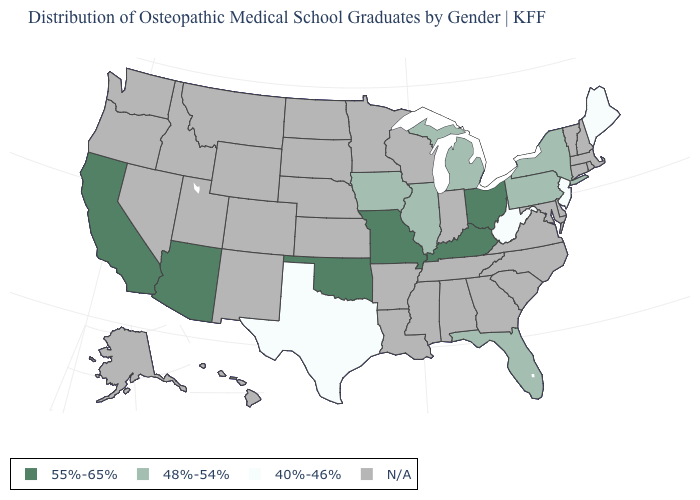Is the legend a continuous bar?
Give a very brief answer. No. What is the value of New York?
Keep it brief. 48%-54%. Which states hav the highest value in the West?
Be succinct. Arizona, California. What is the value of Virginia?
Quick response, please. N/A. Does New Jersey have the lowest value in the Northeast?
Quick response, please. Yes. What is the highest value in the USA?
Answer briefly. 55%-65%. What is the value of Kentucky?
Quick response, please. 55%-65%. Name the states that have a value in the range 40%-46%?
Quick response, please. Maine, New Jersey, Texas, West Virginia. Which states have the lowest value in the South?
Answer briefly. Texas, West Virginia. What is the value of California?
Quick response, please. 55%-65%. Does Illinois have the lowest value in the USA?
Write a very short answer. No. What is the value of Virginia?
Be succinct. N/A. What is the value of North Carolina?
Concise answer only. N/A. What is the value of Oregon?
Keep it brief. N/A. 